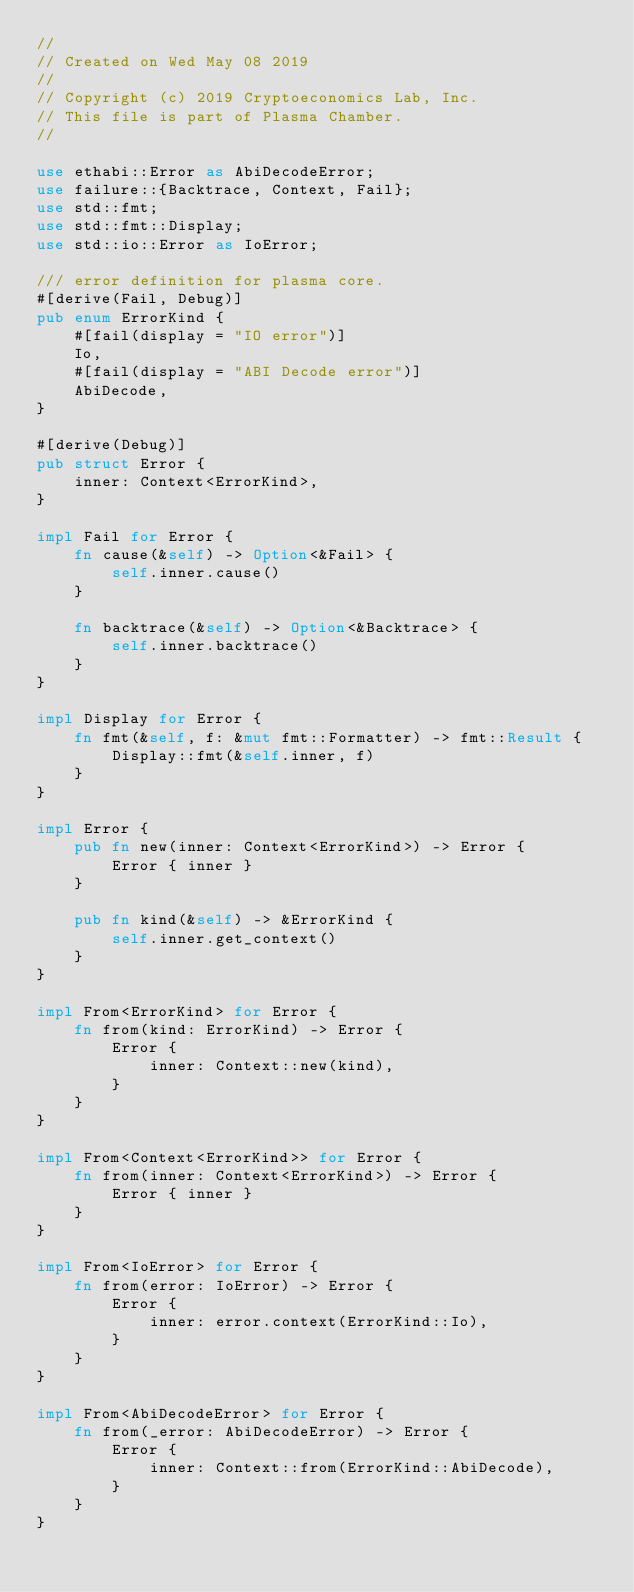Convert code to text. <code><loc_0><loc_0><loc_500><loc_500><_Rust_>//
// Created on Wed May 08 2019
//
// Copyright (c) 2019 Cryptoeconomics Lab, Inc.
// This file is part of Plasma Chamber.
//

use ethabi::Error as AbiDecodeError;
use failure::{Backtrace, Context, Fail};
use std::fmt;
use std::fmt::Display;
use std::io::Error as IoError;

/// error definition for plasma core.
#[derive(Fail, Debug)]
pub enum ErrorKind {
    #[fail(display = "IO error")]
    Io,
    #[fail(display = "ABI Decode error")]
    AbiDecode,
}

#[derive(Debug)]
pub struct Error {
    inner: Context<ErrorKind>,
}

impl Fail for Error {
    fn cause(&self) -> Option<&Fail> {
        self.inner.cause()
    }

    fn backtrace(&self) -> Option<&Backtrace> {
        self.inner.backtrace()
    }
}

impl Display for Error {
    fn fmt(&self, f: &mut fmt::Formatter) -> fmt::Result {
        Display::fmt(&self.inner, f)
    }
}

impl Error {
    pub fn new(inner: Context<ErrorKind>) -> Error {
        Error { inner }
    }

    pub fn kind(&self) -> &ErrorKind {
        self.inner.get_context()
    }
}

impl From<ErrorKind> for Error {
    fn from(kind: ErrorKind) -> Error {
        Error {
            inner: Context::new(kind),
        }
    }
}

impl From<Context<ErrorKind>> for Error {
    fn from(inner: Context<ErrorKind>) -> Error {
        Error { inner }
    }
}

impl From<IoError> for Error {
    fn from(error: IoError) -> Error {
        Error {
            inner: error.context(ErrorKind::Io),
        }
    }
}

impl From<AbiDecodeError> for Error {
    fn from(_error: AbiDecodeError) -> Error {
        Error {
            inner: Context::from(ErrorKind::AbiDecode),
        }
    }
}
</code> 